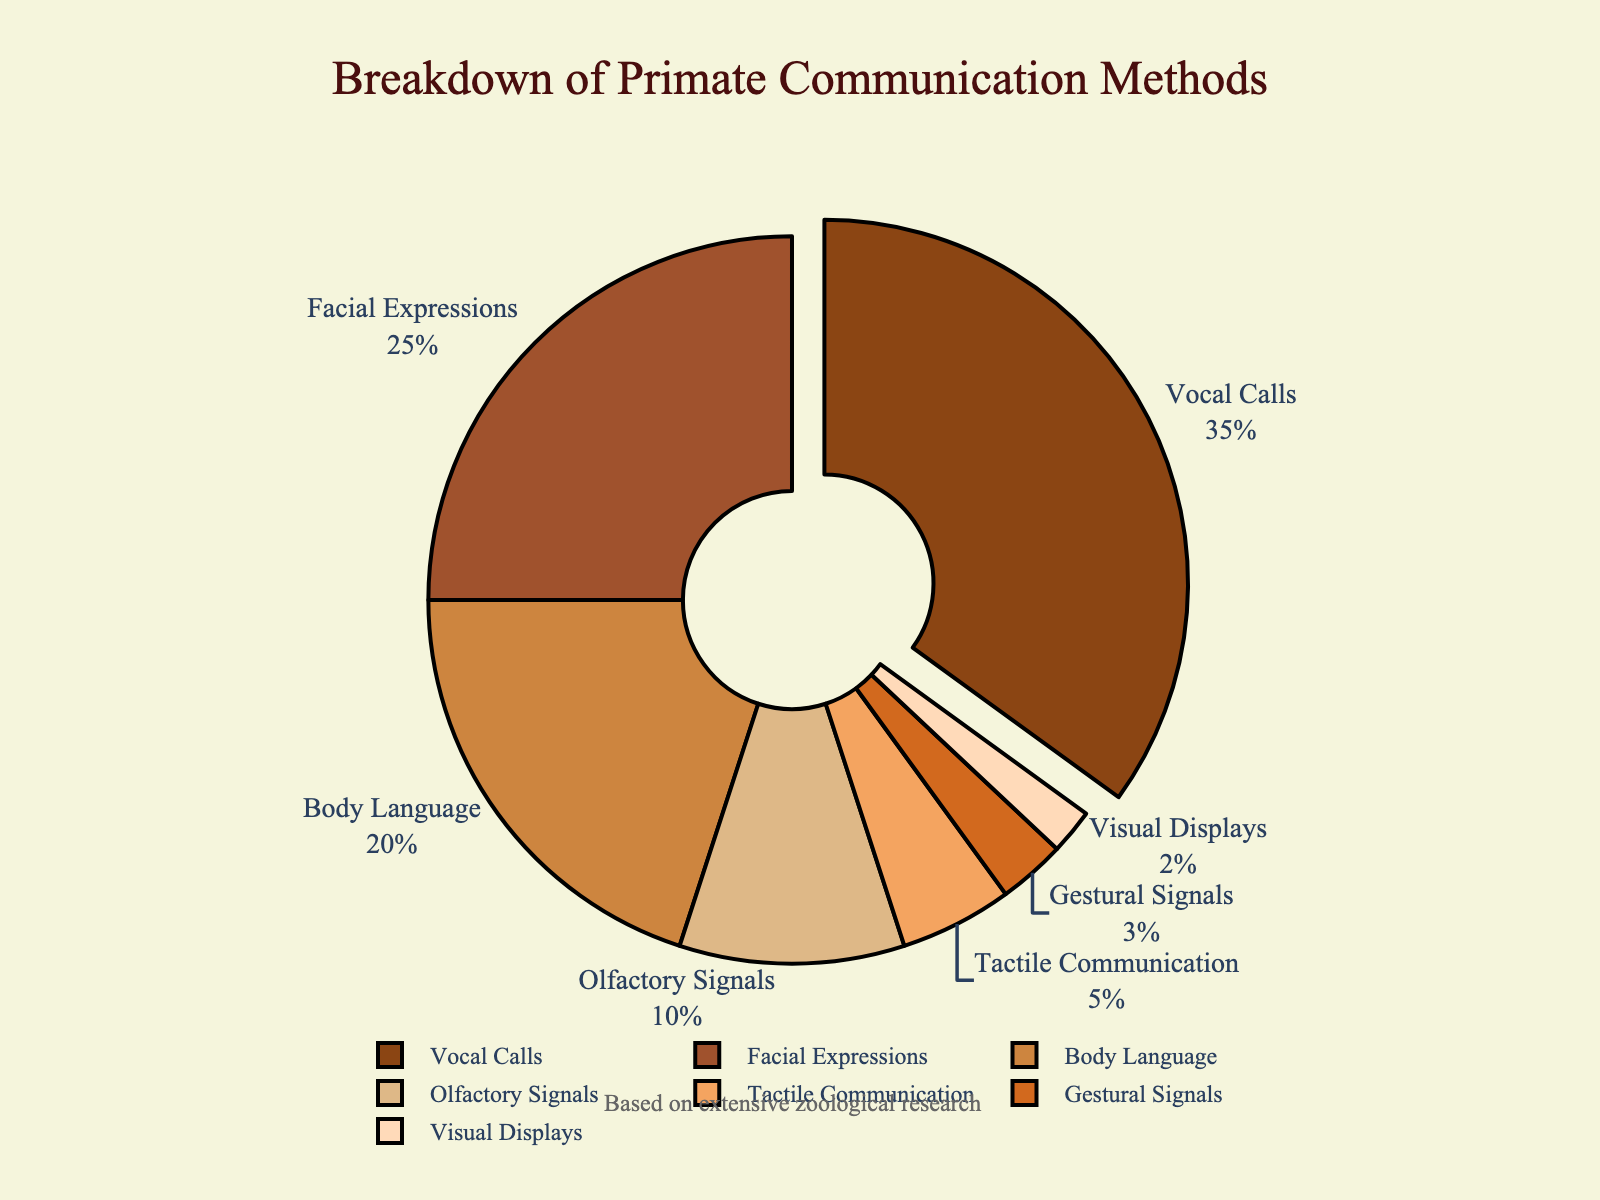Which communication method occupies the largest portion of the chart? Vocal Calls cover the largest portion of the pie chart. This is evident as it has the highest percentage slice.
Answer: Vocal Calls What is the combined percentage of Facial Expressions and Body Language? The percentage for Facial Expressions is 25% and for Body Language is 20%. Adding these together gives 25 + 20 = 45%.
Answer: 45% Which communication method is represented by the smallest slice? Visual Displays are represented by the smallest slice as they account for only 2% of the chart.
Answer: Visual Displays How much larger is the percentage of Vocal Calls compared to Olfactory Signals? Vocal Calls are at 35%, while Olfactory Signals are at 10%. The difference is 35 - 10 = 25%.
Answer: 25% What is the total percentage of communication methods that are represented by slices larger than 15%? Vocal Calls (35%), Facial Expressions (25%), and Body Language (20%) each have slices larger than 15%. Adding these gives 35 + 25 + 20 = 80%.
Answer: 80% How many communication methods constitute less than 10% each? The pie chart shows that Olfactory Signals (10%), Tactile Communication (5%), Gestural Signals (3%), and Visual Displays (2%) each have less than 10%. There are 4 such communication methods.
Answer: 4 What is the difference in percentage between Tactile Communication and Gestural Signals? Tactile Communication is at 5% and Gestural Signals are at 3%. The difference is 5 - 3 = 2%.
Answer: 2% By how much does the percentage of Vocal Calls exceed the sum of Gestural Signals and Visual Displays? The sum of Gestural Signals (3%) and Visual Displays (2%) is 3 + 2 = 5%. The percentage of Vocal Calls is 35%. The difference is 35 - 5 = 30%.
Answer: 30% Which three communication methods together make up 60% of the chart? Adding percentages for Body Language (20%), Olfactory Signals (10%), and Tactile Communication (5%) gives 20 + 10 + 5 = 35%. Including Vocal Calls (35%) makes 35 + 35 = 70%. Now, excluding Tactile Communication (5%) reduces it to 65% (still over); instead exclude Olfactory Signals (10%) after the previous step. Finally includes Facial Expressions (25%). The total exactly adds up to 60%.
Answer: Vocal Calls, Facial Expressions, Body Language 